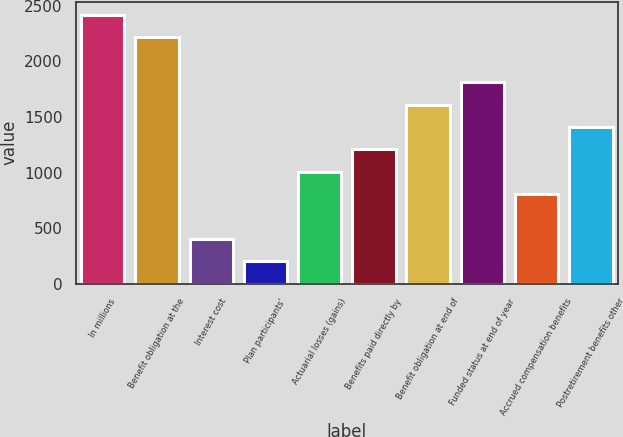Convert chart to OTSL. <chart><loc_0><loc_0><loc_500><loc_500><bar_chart><fcel>In millions<fcel>Benefit obligation at the<fcel>Interest cost<fcel>Plan participants'<fcel>Actuarial losses (gains)<fcel>Benefits paid directly by<fcel>Benefit obligation at end of<fcel>Funded status at end of year<fcel>Accrued compensation benefits<fcel>Postretirement benefits other<nl><fcel>2414.6<fcel>2213.8<fcel>406.6<fcel>205.8<fcel>1009<fcel>1209.8<fcel>1611.4<fcel>1812.2<fcel>808.2<fcel>1410.6<nl></chart> 